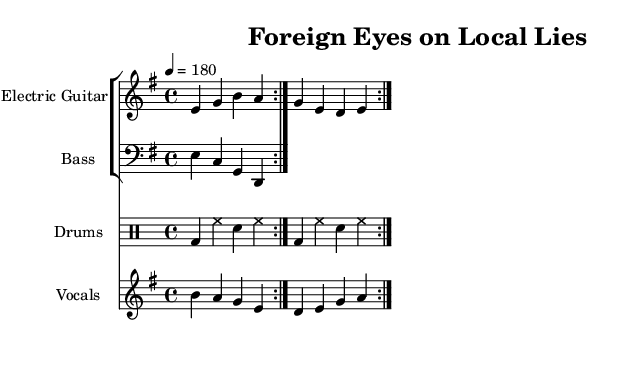What is the key signature of this music? The key signature shows two sharps, indicating it is in E minor, which is the relative minor of G major. This can be directly read from the music notation at the beginning of the score.
Answer: E minor What is the time signature of this music? The time signature is indicated as 4/4, which means there are four beats in each measure, and a quarter note receives one beat. This information is found at the beginning of the score.
Answer: 4/4 What is the tempo marking for this piece? The tempo marking indicates that the piece should be played at a speed of 180 beats per minute. This is specified at the beginning of the score with the notation "4 = 180".
Answer: 180 How many times is the verse repeated? The verse is repeated twice as shown by the "repeat volta 2" notation in the lyrics section of the score, indicating that the entire verse and chorus are played two times.
Answer: 2 What type of drum is indicated in the drum part? The drum part specifies "bd" for bass drum and "sn" for snare drum, clearly showing the instruments to be played in the score with their respective abbreviations.
Answer: Bass drum, snare What lyrical theme does this song address? The lyrics highlight societal issues and critique a flawed system, drawing attention to a political theme related to the perspective from foreign eyes observing the local realities. This can be inferred from the lyrics provided.
Answer: Political critique What instruments are used in this piece? The score features electric guitar, bass guitar, drums, and vocals, as specified in the instrument names on each staff. This includes multiple parts designed for a typical punk setup.
Answer: Electric guitar, bass guitar, drums, vocals 